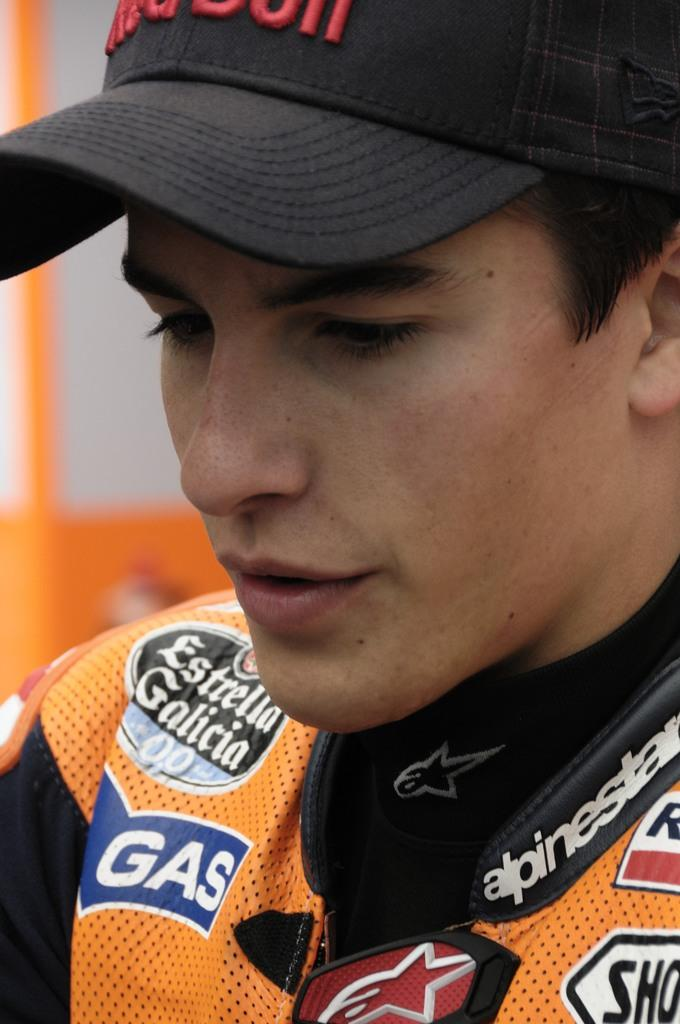<image>
Offer a succinct explanation of the picture presented. Estrella Galicia is the name patched onto this driver's uniform. 